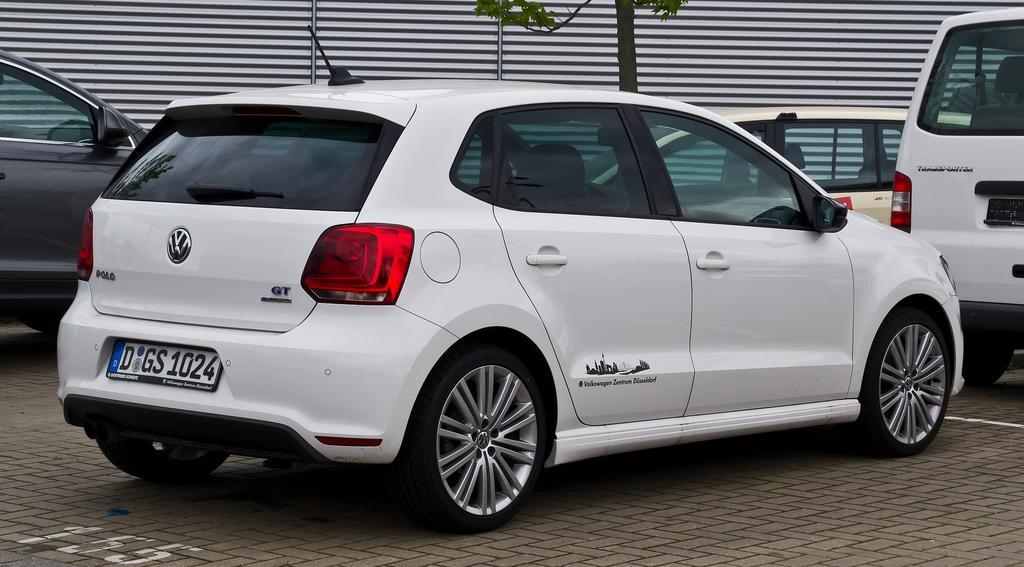Please provide a concise description of this image. In this image there is a car on the floor. Beside it there are few other cars on the floor. In the background there is a wall. On the right side there is a tree. There is an antenna on the car. 